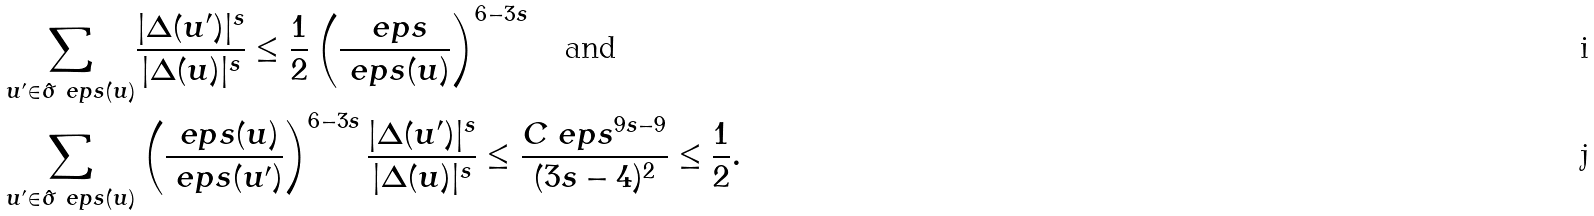<formula> <loc_0><loc_0><loc_500><loc_500>\sum _ { u ^ { \prime } \in \hat { \sigma } _ { \ } e p s ( u ) } & \frac { | \Delta ( u ^ { \prime } ) | ^ { s } } { | \Delta ( u ) | ^ { s } } \leq \frac { 1 } { 2 } \left ( \frac { \ e p s } { \ e p s ( u ) } \right ) ^ { 6 - 3 s } \quad \text {and} \\ \sum _ { u ^ { \prime } \in \hat { \sigma } _ { \ } e p s ( u ) } & \left ( \frac { \ e p s ( u ) } { \ e p s ( u ^ { \prime } ) } \right ) ^ { 6 - 3 s } \frac { | \Delta ( u ^ { \prime } ) | ^ { s } } { | \Delta ( u ) | ^ { s } } \leq \frac { C \ e p s ^ { 9 s - 9 } } { ( 3 s - 4 ) ^ { 2 } } \leq \frac { 1 } { 2 } .</formula> 